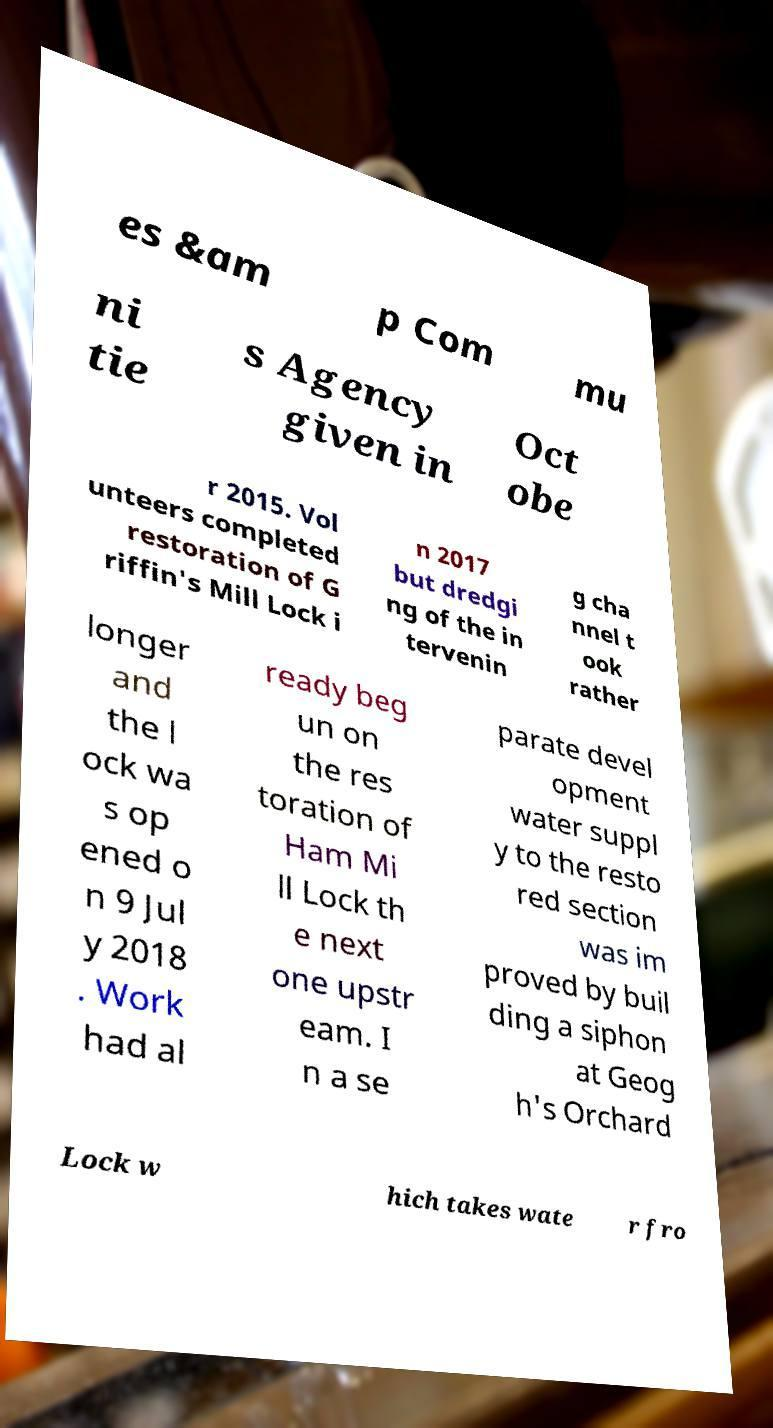For documentation purposes, I need the text within this image transcribed. Could you provide that? es &am p Com mu ni tie s Agency given in Oct obe r 2015. Vol unteers completed restoration of G riffin's Mill Lock i n 2017 but dredgi ng of the in tervenin g cha nnel t ook rather longer and the l ock wa s op ened o n 9 Jul y 2018 . Work had al ready beg un on the res toration of Ham Mi ll Lock th e next one upstr eam. I n a se parate devel opment water suppl y to the resto red section was im proved by buil ding a siphon at Geog h's Orchard Lock w hich takes wate r fro 